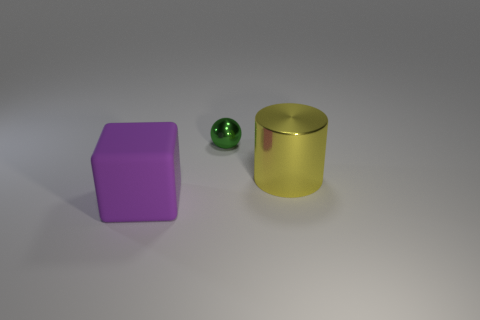This image seems to include three objects, can you tell me their colors? Certainly! Starting from the left, there is a cube with a distinct purple hue, a small sphere with a green tone, and on the right, we have a cylinder with a golden yellow color. 